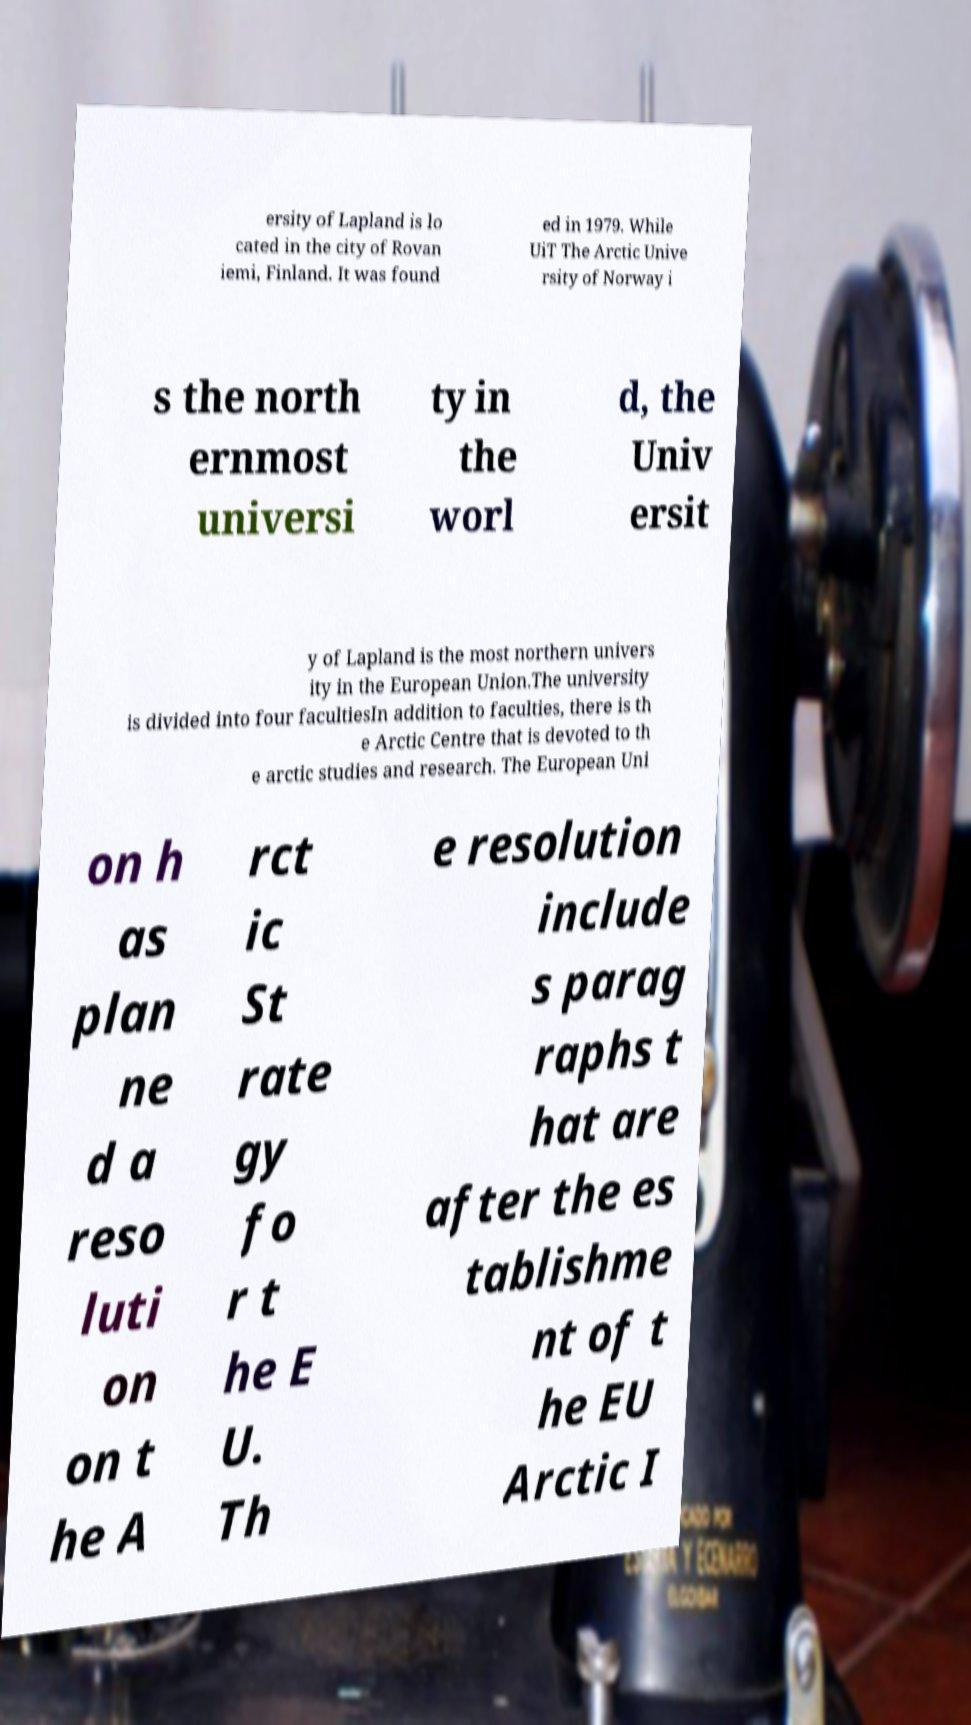Please identify and transcribe the text found in this image. ersity of Lapland is lo cated in the city of Rovan iemi, Finland. It was found ed in 1979. While UiT The Arctic Unive rsity of Norway i s the north ernmost universi ty in the worl d, the Univ ersit y of Lapland is the most northern univers ity in the European Union.The university is divided into four facultiesIn addition to faculties, there is th e Arctic Centre that is devoted to th e arctic studies and research. The European Uni on h as plan ne d a reso luti on on t he A rct ic St rate gy fo r t he E U. Th e resolution include s parag raphs t hat are after the es tablishme nt of t he EU Arctic I 